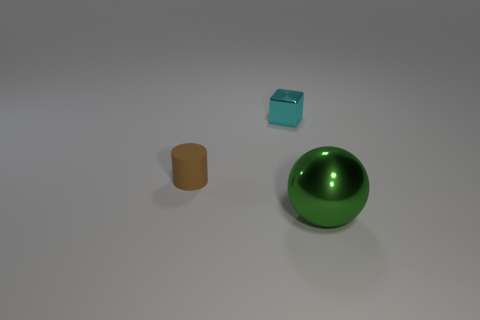Is there anything else that has the same size as the metal ball?
Your answer should be very brief. No. What material is the object right of the object behind the brown rubber cylinder?
Keep it short and to the point. Metal. Is there anything else that is made of the same material as the small brown cylinder?
Offer a terse response. No. Are there fewer green shiny spheres that are on the left side of the tiny cyan object than cubes?
Keep it short and to the point. Yes. What is the color of the metallic object that is behind the thing in front of the tiny cylinder?
Your answer should be very brief. Cyan. How big is the metallic object to the right of the metallic object behind the metallic thing in front of the cyan metallic thing?
Offer a very short reply. Large. Is the number of metal objects that are in front of the cyan metallic object less than the number of objects behind the big metallic thing?
Your answer should be compact. Yes. What number of cyan blocks have the same material as the green sphere?
Ensure brevity in your answer.  1. There is a shiny thing behind the green object in front of the small cyan cube; are there any tiny objects that are in front of it?
Your answer should be very brief. Yes. There is a large thing that is made of the same material as the block; what shape is it?
Give a very brief answer. Sphere. 